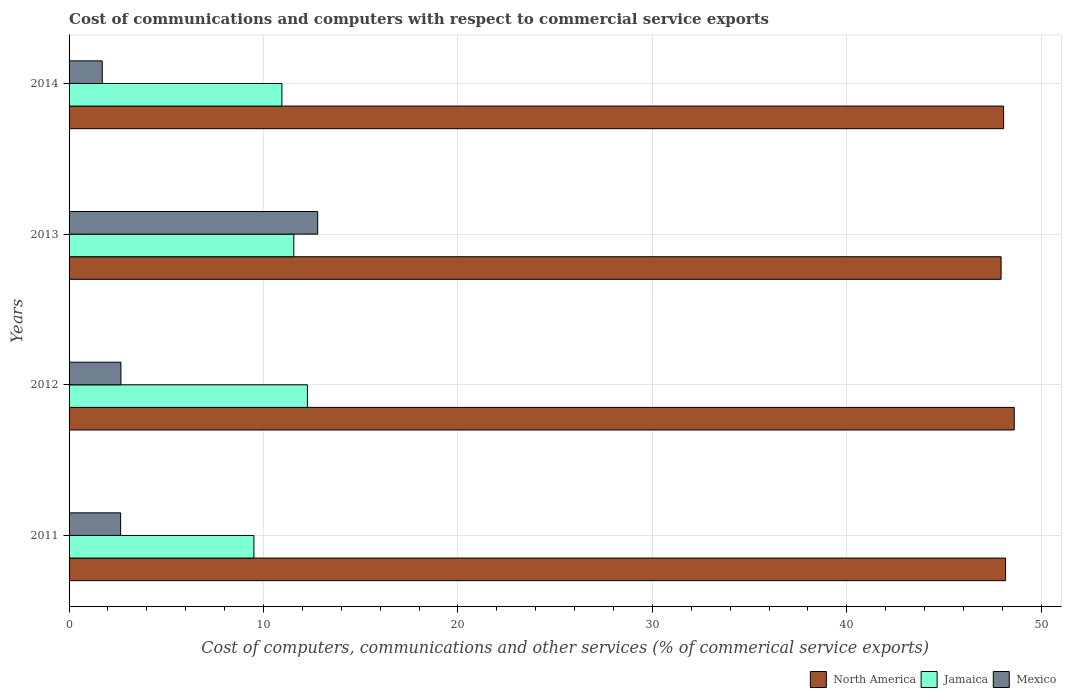How many different coloured bars are there?
Keep it short and to the point. 3. How many bars are there on the 2nd tick from the top?
Your answer should be very brief. 3. What is the cost of communications and computers in North America in 2013?
Make the answer very short. 47.93. Across all years, what is the maximum cost of communications and computers in North America?
Offer a very short reply. 48.61. Across all years, what is the minimum cost of communications and computers in Jamaica?
Offer a very short reply. 9.51. In which year was the cost of communications and computers in Mexico minimum?
Keep it short and to the point. 2014. What is the total cost of communications and computers in Jamaica in the graph?
Offer a terse response. 44.27. What is the difference between the cost of communications and computers in Mexico in 2013 and that in 2014?
Give a very brief answer. 11.08. What is the difference between the cost of communications and computers in Jamaica in 2014 and the cost of communications and computers in Mexico in 2013?
Ensure brevity in your answer.  -1.84. What is the average cost of communications and computers in Jamaica per year?
Your answer should be compact. 11.07. In the year 2014, what is the difference between the cost of communications and computers in North America and cost of communications and computers in Mexico?
Offer a very short reply. 46.36. In how many years, is the cost of communications and computers in Mexico greater than 38 %?
Your answer should be compact. 0. What is the ratio of the cost of communications and computers in North America in 2012 to that in 2013?
Offer a terse response. 1.01. Is the cost of communications and computers in North America in 2012 less than that in 2014?
Your answer should be compact. No. What is the difference between the highest and the second highest cost of communications and computers in Jamaica?
Your answer should be compact. 0.7. What is the difference between the highest and the lowest cost of communications and computers in North America?
Keep it short and to the point. 0.68. In how many years, is the cost of communications and computers in Jamaica greater than the average cost of communications and computers in Jamaica taken over all years?
Keep it short and to the point. 2. What does the 1st bar from the top in 2014 represents?
Offer a terse response. Mexico. What does the 2nd bar from the bottom in 2013 represents?
Keep it short and to the point. Jamaica. Is it the case that in every year, the sum of the cost of communications and computers in Jamaica and cost of communications and computers in North America is greater than the cost of communications and computers in Mexico?
Give a very brief answer. Yes. Are all the bars in the graph horizontal?
Offer a very short reply. Yes. How many years are there in the graph?
Provide a short and direct response. 4. What is the difference between two consecutive major ticks on the X-axis?
Your answer should be compact. 10. Are the values on the major ticks of X-axis written in scientific E-notation?
Offer a very short reply. No. Does the graph contain any zero values?
Your response must be concise. No. How many legend labels are there?
Keep it short and to the point. 3. How are the legend labels stacked?
Give a very brief answer. Horizontal. What is the title of the graph?
Make the answer very short. Cost of communications and computers with respect to commercial service exports. What is the label or title of the X-axis?
Ensure brevity in your answer.  Cost of computers, communications and other services (% of commerical service exports). What is the Cost of computers, communications and other services (% of commerical service exports) in North America in 2011?
Your answer should be compact. 48.16. What is the Cost of computers, communications and other services (% of commerical service exports) in Jamaica in 2011?
Give a very brief answer. 9.51. What is the Cost of computers, communications and other services (% of commerical service exports) in Mexico in 2011?
Your answer should be compact. 2.65. What is the Cost of computers, communications and other services (% of commerical service exports) of North America in 2012?
Keep it short and to the point. 48.61. What is the Cost of computers, communications and other services (% of commerical service exports) in Jamaica in 2012?
Make the answer very short. 12.26. What is the Cost of computers, communications and other services (% of commerical service exports) of Mexico in 2012?
Your answer should be very brief. 2.67. What is the Cost of computers, communications and other services (% of commerical service exports) of North America in 2013?
Provide a succinct answer. 47.93. What is the Cost of computers, communications and other services (% of commerical service exports) of Jamaica in 2013?
Make the answer very short. 11.56. What is the Cost of computers, communications and other services (% of commerical service exports) in Mexico in 2013?
Offer a very short reply. 12.79. What is the Cost of computers, communications and other services (% of commerical service exports) in North America in 2014?
Ensure brevity in your answer.  48.06. What is the Cost of computers, communications and other services (% of commerical service exports) in Jamaica in 2014?
Keep it short and to the point. 10.95. What is the Cost of computers, communications and other services (% of commerical service exports) of Mexico in 2014?
Offer a very short reply. 1.71. Across all years, what is the maximum Cost of computers, communications and other services (% of commerical service exports) of North America?
Your answer should be very brief. 48.61. Across all years, what is the maximum Cost of computers, communications and other services (% of commerical service exports) in Jamaica?
Give a very brief answer. 12.26. Across all years, what is the maximum Cost of computers, communications and other services (% of commerical service exports) in Mexico?
Your answer should be compact. 12.79. Across all years, what is the minimum Cost of computers, communications and other services (% of commerical service exports) in North America?
Provide a succinct answer. 47.93. Across all years, what is the minimum Cost of computers, communications and other services (% of commerical service exports) of Jamaica?
Make the answer very short. 9.51. Across all years, what is the minimum Cost of computers, communications and other services (% of commerical service exports) of Mexico?
Your answer should be very brief. 1.71. What is the total Cost of computers, communications and other services (% of commerical service exports) of North America in the graph?
Your response must be concise. 192.77. What is the total Cost of computers, communications and other services (% of commerical service exports) of Jamaica in the graph?
Your response must be concise. 44.27. What is the total Cost of computers, communications and other services (% of commerical service exports) of Mexico in the graph?
Your response must be concise. 19.81. What is the difference between the Cost of computers, communications and other services (% of commerical service exports) in North America in 2011 and that in 2012?
Offer a very short reply. -0.45. What is the difference between the Cost of computers, communications and other services (% of commerical service exports) of Jamaica in 2011 and that in 2012?
Your answer should be very brief. -2.75. What is the difference between the Cost of computers, communications and other services (% of commerical service exports) in Mexico in 2011 and that in 2012?
Offer a very short reply. -0.01. What is the difference between the Cost of computers, communications and other services (% of commerical service exports) of North America in 2011 and that in 2013?
Offer a very short reply. 0.23. What is the difference between the Cost of computers, communications and other services (% of commerical service exports) of Jamaica in 2011 and that in 2013?
Offer a terse response. -2.05. What is the difference between the Cost of computers, communications and other services (% of commerical service exports) of Mexico in 2011 and that in 2013?
Provide a succinct answer. -10.13. What is the difference between the Cost of computers, communications and other services (% of commerical service exports) of North America in 2011 and that in 2014?
Offer a terse response. 0.1. What is the difference between the Cost of computers, communications and other services (% of commerical service exports) of Jamaica in 2011 and that in 2014?
Offer a terse response. -1.44. What is the difference between the Cost of computers, communications and other services (% of commerical service exports) in Mexico in 2011 and that in 2014?
Provide a short and direct response. 0.95. What is the difference between the Cost of computers, communications and other services (% of commerical service exports) of North America in 2012 and that in 2013?
Your response must be concise. 0.68. What is the difference between the Cost of computers, communications and other services (% of commerical service exports) in Jamaica in 2012 and that in 2013?
Your answer should be compact. 0.7. What is the difference between the Cost of computers, communications and other services (% of commerical service exports) in Mexico in 2012 and that in 2013?
Offer a terse response. -10.12. What is the difference between the Cost of computers, communications and other services (% of commerical service exports) of North America in 2012 and that in 2014?
Your response must be concise. 0.55. What is the difference between the Cost of computers, communications and other services (% of commerical service exports) of Jamaica in 2012 and that in 2014?
Give a very brief answer. 1.31. What is the difference between the Cost of computers, communications and other services (% of commerical service exports) in Mexico in 2012 and that in 2014?
Offer a very short reply. 0.96. What is the difference between the Cost of computers, communications and other services (% of commerical service exports) in North America in 2013 and that in 2014?
Provide a succinct answer. -0.13. What is the difference between the Cost of computers, communications and other services (% of commerical service exports) in Jamaica in 2013 and that in 2014?
Your answer should be very brief. 0.61. What is the difference between the Cost of computers, communications and other services (% of commerical service exports) of Mexico in 2013 and that in 2014?
Provide a succinct answer. 11.08. What is the difference between the Cost of computers, communications and other services (% of commerical service exports) of North America in 2011 and the Cost of computers, communications and other services (% of commerical service exports) of Jamaica in 2012?
Your response must be concise. 35.9. What is the difference between the Cost of computers, communications and other services (% of commerical service exports) in North America in 2011 and the Cost of computers, communications and other services (% of commerical service exports) in Mexico in 2012?
Give a very brief answer. 45.5. What is the difference between the Cost of computers, communications and other services (% of commerical service exports) in Jamaica in 2011 and the Cost of computers, communications and other services (% of commerical service exports) in Mexico in 2012?
Offer a terse response. 6.84. What is the difference between the Cost of computers, communications and other services (% of commerical service exports) of North America in 2011 and the Cost of computers, communications and other services (% of commerical service exports) of Jamaica in 2013?
Ensure brevity in your answer.  36.6. What is the difference between the Cost of computers, communications and other services (% of commerical service exports) of North America in 2011 and the Cost of computers, communications and other services (% of commerical service exports) of Mexico in 2013?
Your answer should be compact. 35.38. What is the difference between the Cost of computers, communications and other services (% of commerical service exports) of Jamaica in 2011 and the Cost of computers, communications and other services (% of commerical service exports) of Mexico in 2013?
Your answer should be very brief. -3.28. What is the difference between the Cost of computers, communications and other services (% of commerical service exports) of North America in 2011 and the Cost of computers, communications and other services (% of commerical service exports) of Jamaica in 2014?
Give a very brief answer. 37.22. What is the difference between the Cost of computers, communications and other services (% of commerical service exports) of North America in 2011 and the Cost of computers, communications and other services (% of commerical service exports) of Mexico in 2014?
Offer a very short reply. 46.46. What is the difference between the Cost of computers, communications and other services (% of commerical service exports) in Jamaica in 2011 and the Cost of computers, communications and other services (% of commerical service exports) in Mexico in 2014?
Your response must be concise. 7.8. What is the difference between the Cost of computers, communications and other services (% of commerical service exports) of North America in 2012 and the Cost of computers, communications and other services (% of commerical service exports) of Jamaica in 2013?
Provide a short and direct response. 37.05. What is the difference between the Cost of computers, communications and other services (% of commerical service exports) in North America in 2012 and the Cost of computers, communications and other services (% of commerical service exports) in Mexico in 2013?
Offer a very short reply. 35.82. What is the difference between the Cost of computers, communications and other services (% of commerical service exports) of Jamaica in 2012 and the Cost of computers, communications and other services (% of commerical service exports) of Mexico in 2013?
Provide a short and direct response. -0.53. What is the difference between the Cost of computers, communications and other services (% of commerical service exports) in North America in 2012 and the Cost of computers, communications and other services (% of commerical service exports) in Jamaica in 2014?
Offer a very short reply. 37.66. What is the difference between the Cost of computers, communications and other services (% of commerical service exports) in North America in 2012 and the Cost of computers, communications and other services (% of commerical service exports) in Mexico in 2014?
Your answer should be compact. 46.9. What is the difference between the Cost of computers, communications and other services (% of commerical service exports) of Jamaica in 2012 and the Cost of computers, communications and other services (% of commerical service exports) of Mexico in 2014?
Your answer should be very brief. 10.55. What is the difference between the Cost of computers, communications and other services (% of commerical service exports) of North America in 2013 and the Cost of computers, communications and other services (% of commerical service exports) of Jamaica in 2014?
Your answer should be very brief. 36.99. What is the difference between the Cost of computers, communications and other services (% of commerical service exports) in North America in 2013 and the Cost of computers, communications and other services (% of commerical service exports) in Mexico in 2014?
Make the answer very short. 46.23. What is the difference between the Cost of computers, communications and other services (% of commerical service exports) in Jamaica in 2013 and the Cost of computers, communications and other services (% of commerical service exports) in Mexico in 2014?
Keep it short and to the point. 9.85. What is the average Cost of computers, communications and other services (% of commerical service exports) in North America per year?
Provide a succinct answer. 48.19. What is the average Cost of computers, communications and other services (% of commerical service exports) of Jamaica per year?
Provide a short and direct response. 11.07. What is the average Cost of computers, communications and other services (% of commerical service exports) in Mexico per year?
Give a very brief answer. 4.95. In the year 2011, what is the difference between the Cost of computers, communications and other services (% of commerical service exports) in North America and Cost of computers, communications and other services (% of commerical service exports) in Jamaica?
Your response must be concise. 38.66. In the year 2011, what is the difference between the Cost of computers, communications and other services (% of commerical service exports) of North America and Cost of computers, communications and other services (% of commerical service exports) of Mexico?
Offer a very short reply. 45.51. In the year 2011, what is the difference between the Cost of computers, communications and other services (% of commerical service exports) in Jamaica and Cost of computers, communications and other services (% of commerical service exports) in Mexico?
Keep it short and to the point. 6.85. In the year 2012, what is the difference between the Cost of computers, communications and other services (% of commerical service exports) in North America and Cost of computers, communications and other services (% of commerical service exports) in Jamaica?
Ensure brevity in your answer.  36.35. In the year 2012, what is the difference between the Cost of computers, communications and other services (% of commerical service exports) in North America and Cost of computers, communications and other services (% of commerical service exports) in Mexico?
Make the answer very short. 45.94. In the year 2012, what is the difference between the Cost of computers, communications and other services (% of commerical service exports) of Jamaica and Cost of computers, communications and other services (% of commerical service exports) of Mexico?
Offer a terse response. 9.59. In the year 2013, what is the difference between the Cost of computers, communications and other services (% of commerical service exports) in North America and Cost of computers, communications and other services (% of commerical service exports) in Jamaica?
Provide a succinct answer. 36.37. In the year 2013, what is the difference between the Cost of computers, communications and other services (% of commerical service exports) in North America and Cost of computers, communications and other services (% of commerical service exports) in Mexico?
Keep it short and to the point. 35.15. In the year 2013, what is the difference between the Cost of computers, communications and other services (% of commerical service exports) of Jamaica and Cost of computers, communications and other services (% of commerical service exports) of Mexico?
Your response must be concise. -1.23. In the year 2014, what is the difference between the Cost of computers, communications and other services (% of commerical service exports) in North America and Cost of computers, communications and other services (% of commerical service exports) in Jamaica?
Your answer should be very brief. 37.12. In the year 2014, what is the difference between the Cost of computers, communications and other services (% of commerical service exports) of North America and Cost of computers, communications and other services (% of commerical service exports) of Mexico?
Your response must be concise. 46.36. In the year 2014, what is the difference between the Cost of computers, communications and other services (% of commerical service exports) of Jamaica and Cost of computers, communications and other services (% of commerical service exports) of Mexico?
Offer a very short reply. 9.24. What is the ratio of the Cost of computers, communications and other services (% of commerical service exports) in North America in 2011 to that in 2012?
Provide a short and direct response. 0.99. What is the ratio of the Cost of computers, communications and other services (% of commerical service exports) in Jamaica in 2011 to that in 2012?
Your response must be concise. 0.78. What is the ratio of the Cost of computers, communications and other services (% of commerical service exports) of Mexico in 2011 to that in 2012?
Your answer should be very brief. 0.99. What is the ratio of the Cost of computers, communications and other services (% of commerical service exports) in Jamaica in 2011 to that in 2013?
Your answer should be compact. 0.82. What is the ratio of the Cost of computers, communications and other services (% of commerical service exports) of Mexico in 2011 to that in 2013?
Make the answer very short. 0.21. What is the ratio of the Cost of computers, communications and other services (% of commerical service exports) in North America in 2011 to that in 2014?
Your answer should be very brief. 1. What is the ratio of the Cost of computers, communications and other services (% of commerical service exports) of Jamaica in 2011 to that in 2014?
Keep it short and to the point. 0.87. What is the ratio of the Cost of computers, communications and other services (% of commerical service exports) in Mexico in 2011 to that in 2014?
Provide a short and direct response. 1.55. What is the ratio of the Cost of computers, communications and other services (% of commerical service exports) of North America in 2012 to that in 2013?
Provide a short and direct response. 1.01. What is the ratio of the Cost of computers, communications and other services (% of commerical service exports) in Jamaica in 2012 to that in 2013?
Provide a succinct answer. 1.06. What is the ratio of the Cost of computers, communications and other services (% of commerical service exports) in Mexico in 2012 to that in 2013?
Keep it short and to the point. 0.21. What is the ratio of the Cost of computers, communications and other services (% of commerical service exports) of North America in 2012 to that in 2014?
Ensure brevity in your answer.  1.01. What is the ratio of the Cost of computers, communications and other services (% of commerical service exports) in Jamaica in 2012 to that in 2014?
Offer a very short reply. 1.12. What is the ratio of the Cost of computers, communications and other services (% of commerical service exports) in Mexico in 2012 to that in 2014?
Your answer should be compact. 1.56. What is the ratio of the Cost of computers, communications and other services (% of commerical service exports) of North America in 2013 to that in 2014?
Your answer should be very brief. 1. What is the ratio of the Cost of computers, communications and other services (% of commerical service exports) of Jamaica in 2013 to that in 2014?
Ensure brevity in your answer.  1.06. What is the ratio of the Cost of computers, communications and other services (% of commerical service exports) in Mexico in 2013 to that in 2014?
Make the answer very short. 7.49. What is the difference between the highest and the second highest Cost of computers, communications and other services (% of commerical service exports) of North America?
Give a very brief answer. 0.45. What is the difference between the highest and the second highest Cost of computers, communications and other services (% of commerical service exports) in Jamaica?
Give a very brief answer. 0.7. What is the difference between the highest and the second highest Cost of computers, communications and other services (% of commerical service exports) in Mexico?
Give a very brief answer. 10.12. What is the difference between the highest and the lowest Cost of computers, communications and other services (% of commerical service exports) of North America?
Keep it short and to the point. 0.68. What is the difference between the highest and the lowest Cost of computers, communications and other services (% of commerical service exports) of Jamaica?
Keep it short and to the point. 2.75. What is the difference between the highest and the lowest Cost of computers, communications and other services (% of commerical service exports) of Mexico?
Your response must be concise. 11.08. 